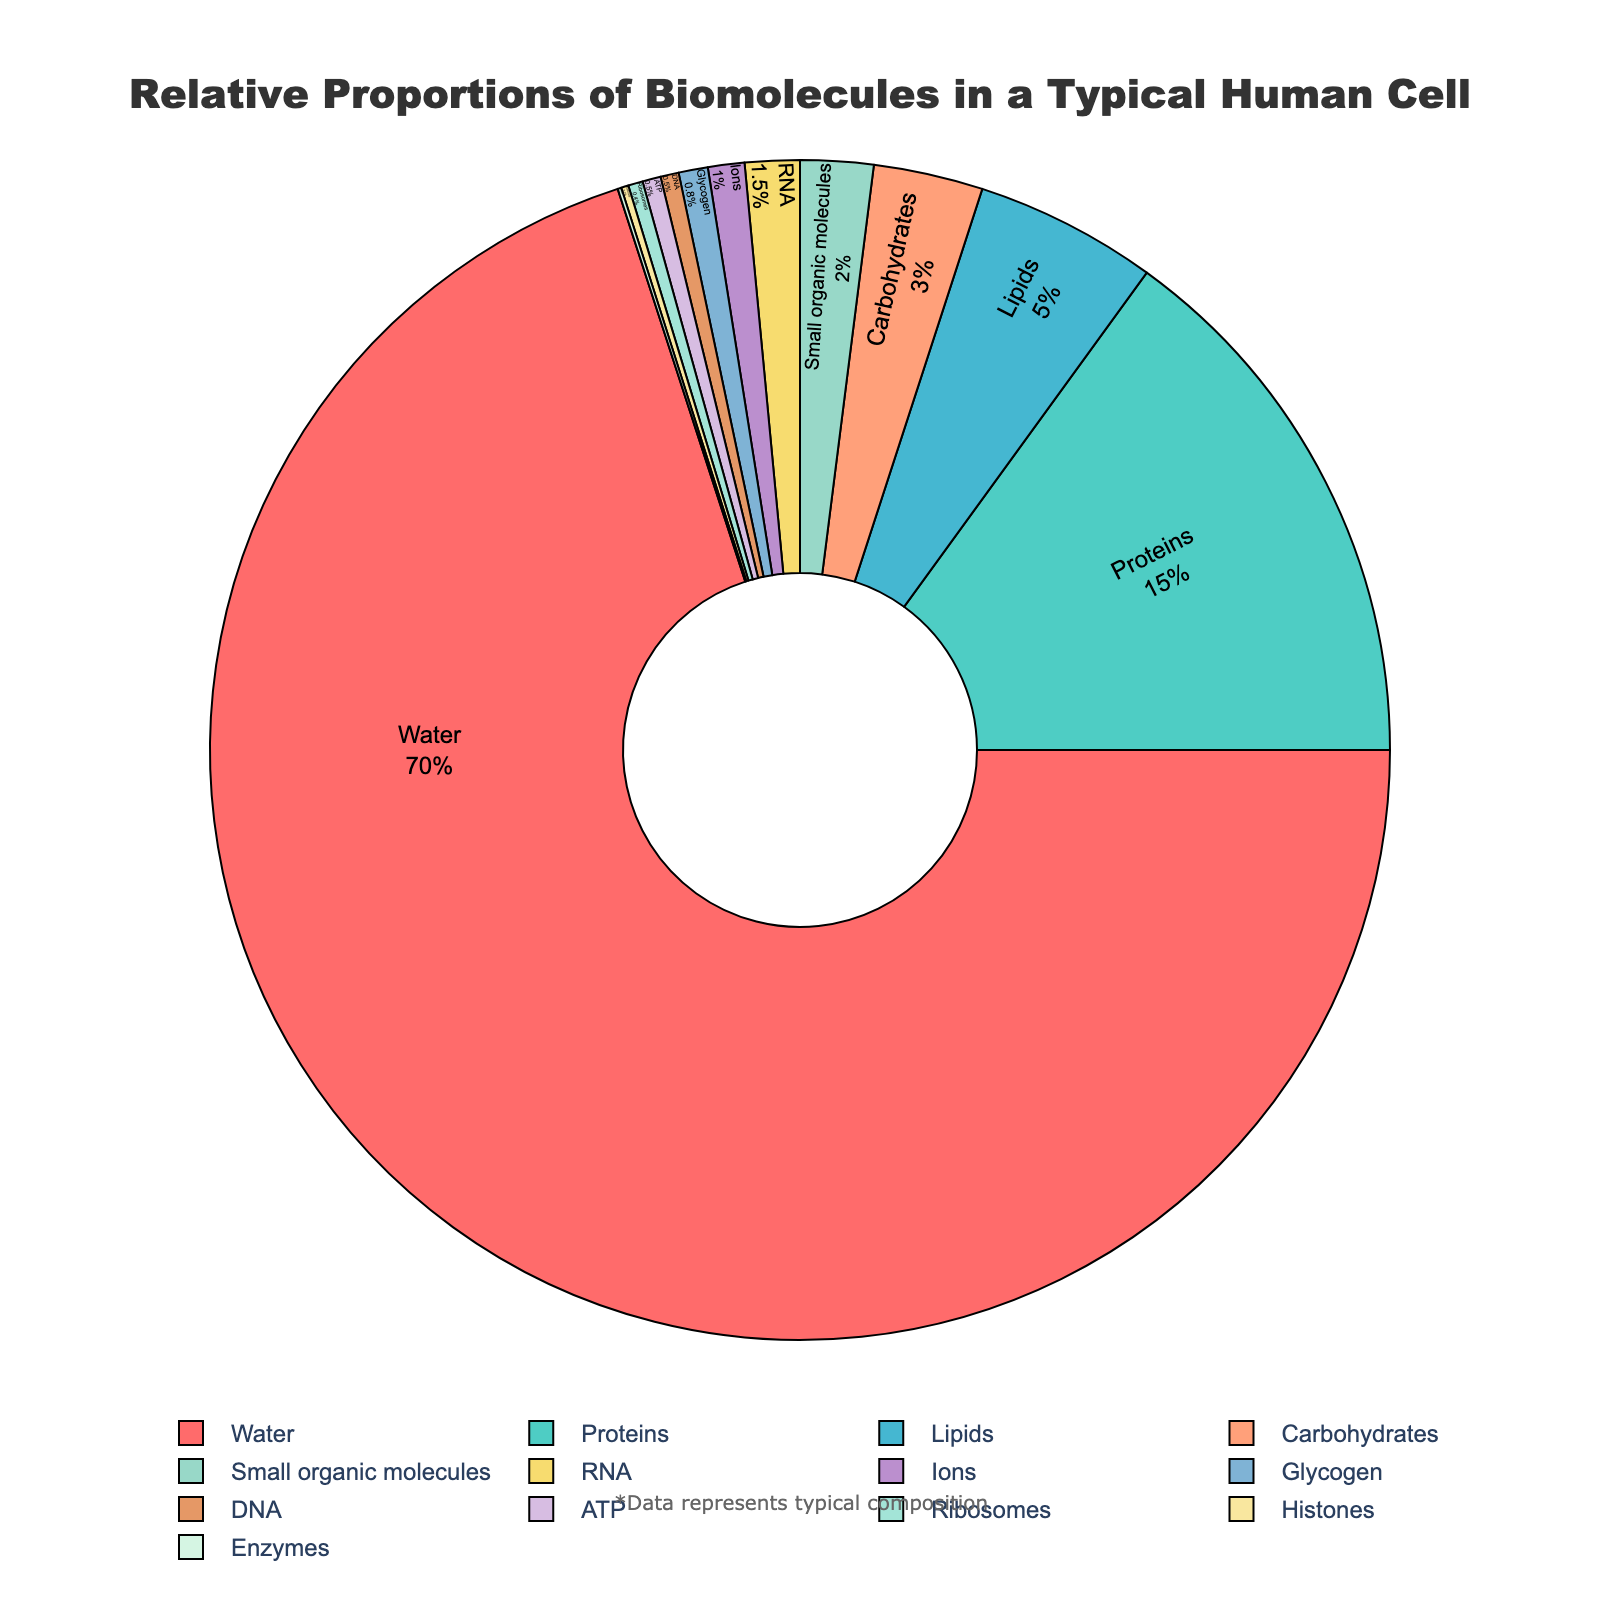what biomolecule takes up the largest proportion in the cell? By observing the pie chart, the largest portion is visually significant and labeled as "Water," which takes up the majority of the pie chart
Answer: Water How much more percentage does water comprise compared to proteins? From the pie chart, "Water" is 70%, and "Proteins" is 15%. The difference is calculated as 70% - 15% = 55%
Answer: 55% Which biomolecules together constitute exactly 5% of the cell's composition? Looking at the pie chart, two biomolecules, "Lipids" (5%) fit the requirement exactly
Answer: Lipids What is the combined percentage of carbohydrates and RNA? From the pie chart: Carbohydrates is 3%, RNA is 1.5%, combined they total 3% + 1.5% = 4.5%
Answer: 4.5% Are there more small organic molecules or ATP in the cell, and by how much? According to the pie chart: Small organic molecules comprise 2%, and ATP comprises 0.5%. The difference is 2% - 0.5% = 1.5%
Answer: Small organic molecules, 1.5% Which three biomolecules have the smallest proportions in the pie chart? By inspecting the pie chart, "Enzymes" (0.1%), "Histones" (0.2%), and "Ribosomes" (0.4%) are the smallest proportions
Answer: Enzymes, Histones, Ribosomes What is the proportion of ions relative to RNA? "Ions" comprise 1% and "RNA" comprises 1.5% from the pie chart. The ratio is 1% / 1.5% = 2/3 or approximately 0.67
Answer: 0.67 Which biomolecule labeled in the pie chart is shown in green? The pie chart annotates "Proteins" with the color green
Answer: Proteins What is the total percentage of all biomolecules taking up less than 2% each? From the pie chart, these are: RNA (1.5%), DNA (0.5%), Ions (1%), ATP (0.5%), Glycogen (0.8%), Ribosomes (0.4%), Histones (0.2%), Enzymes (0.1%). Total percentage is 1.5% + 0.5% + 1% + 0.5% + 0.8% + 0.4% + 0.2% + 0.1% = 5%
Answer: 5% Are there more ions or carbohydrates in the cell? Comparing the percentages from the pie chart: Ions are 1%, Carbohydrates are 3%. Thus, there are more Carbohydrates
Answer: Carbohydrates 